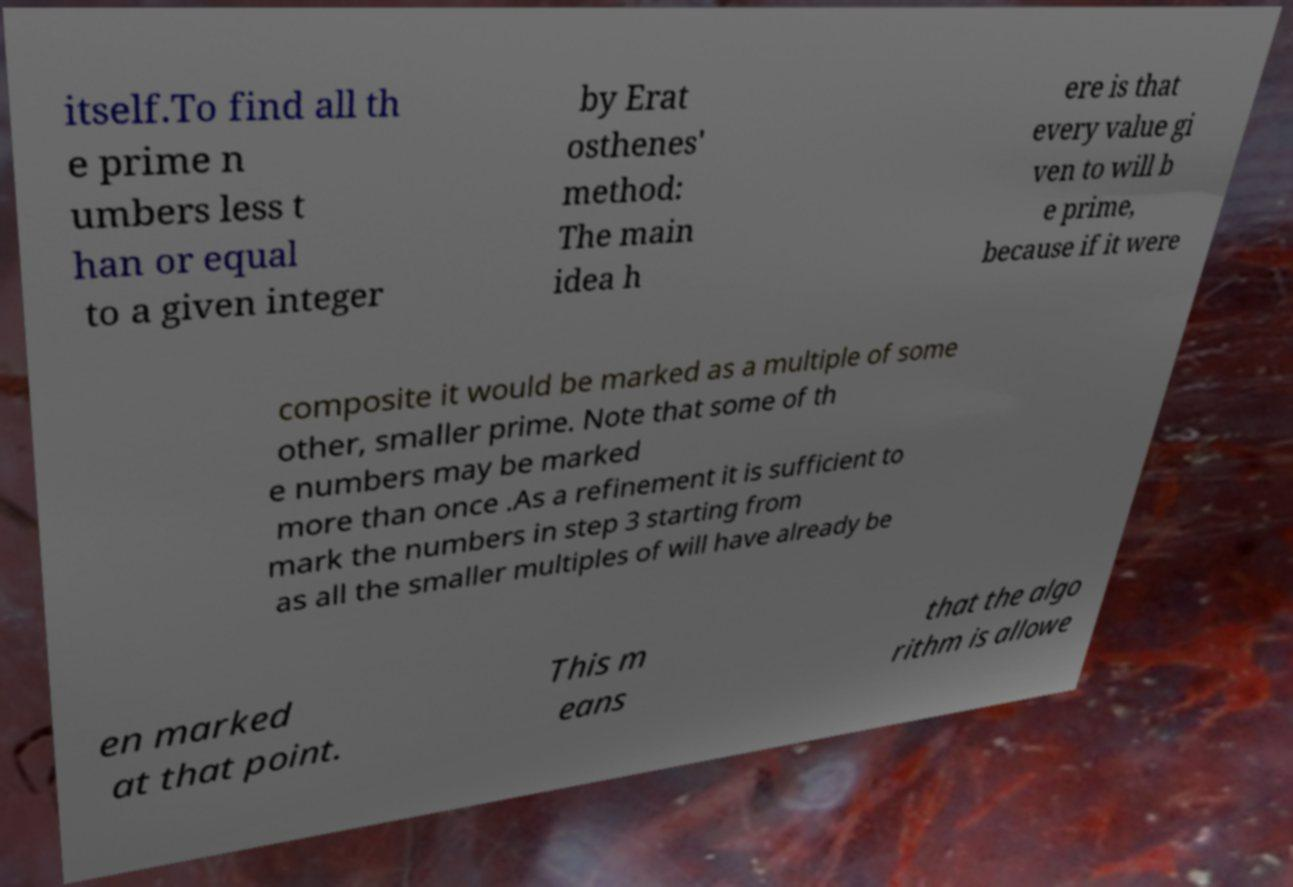There's text embedded in this image that I need extracted. Can you transcribe it verbatim? itself.To find all th e prime n umbers less t han or equal to a given integer by Erat osthenes' method: The main idea h ere is that every value gi ven to will b e prime, because if it were composite it would be marked as a multiple of some other, smaller prime. Note that some of th e numbers may be marked more than once .As a refinement it is sufficient to mark the numbers in step 3 starting from as all the smaller multiples of will have already be en marked at that point. This m eans that the algo rithm is allowe 